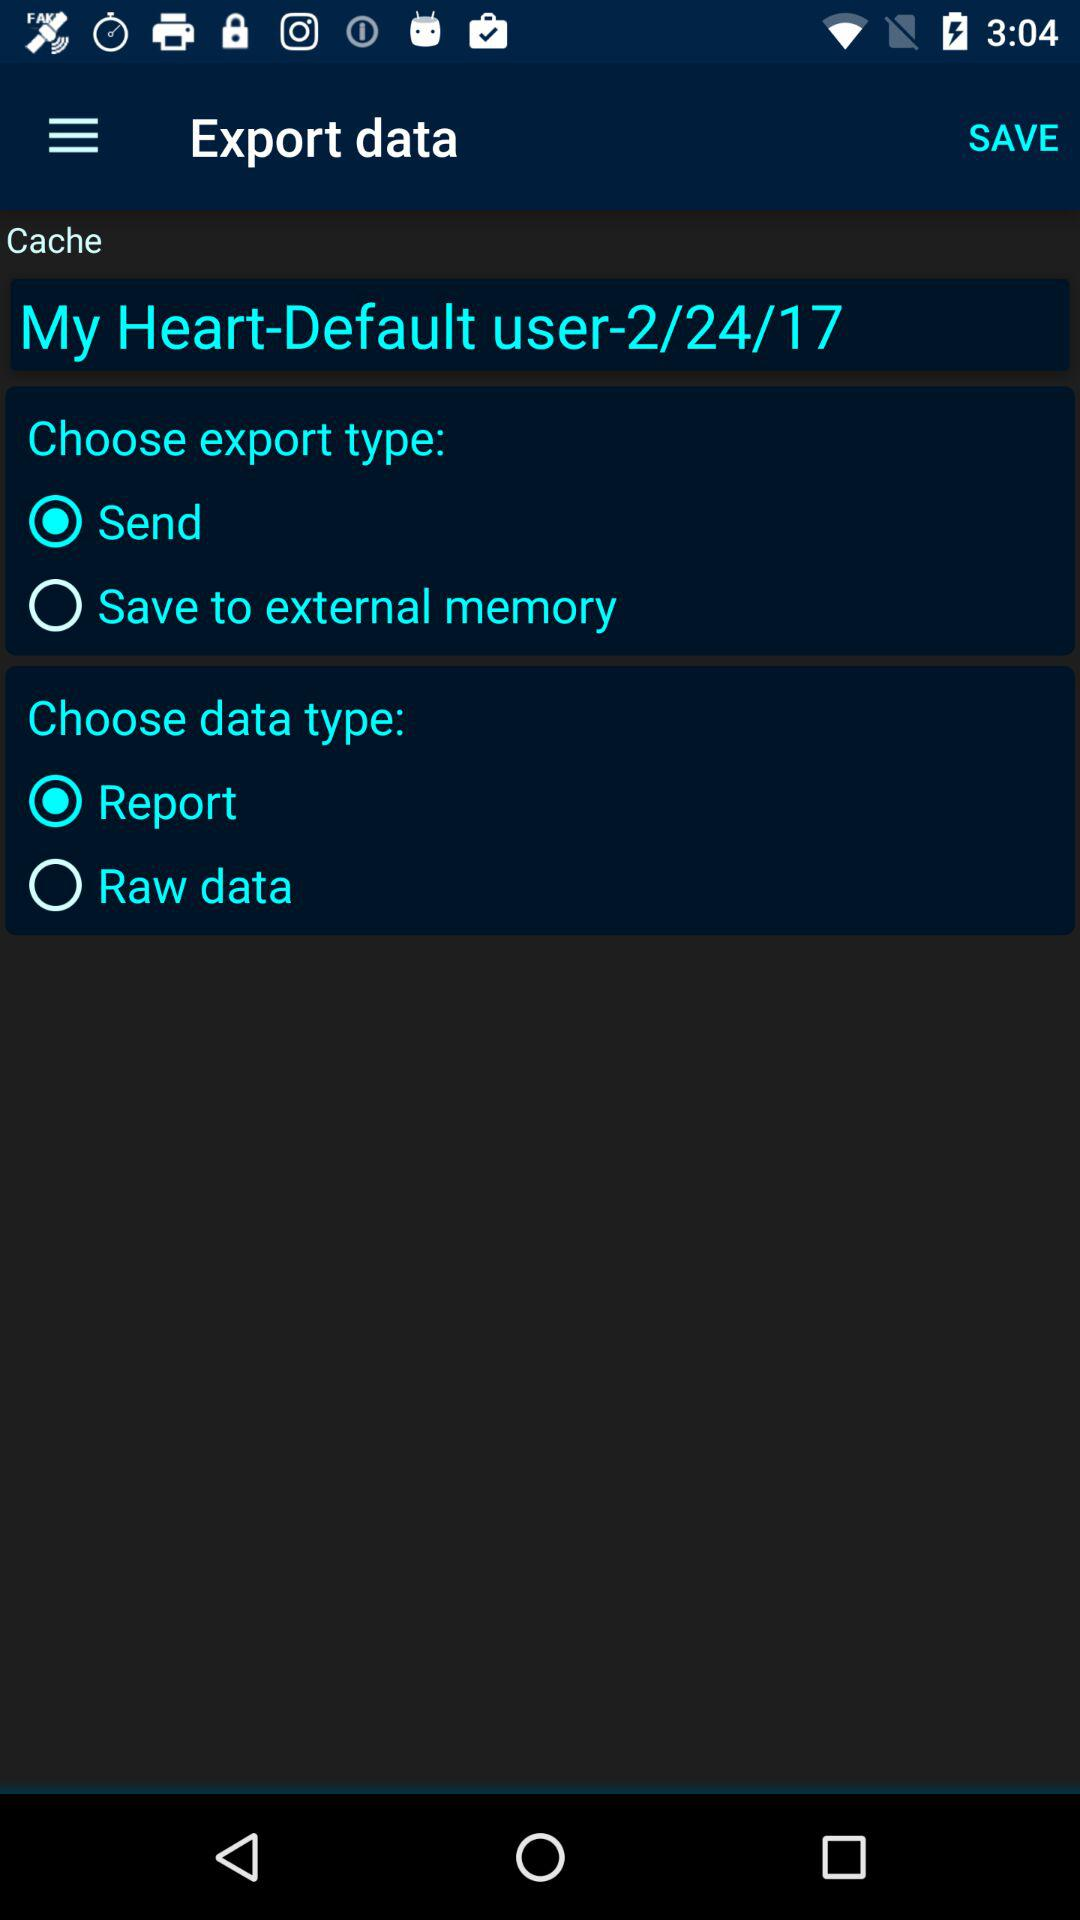Which export type has been selected? The selected export type is "Send". 